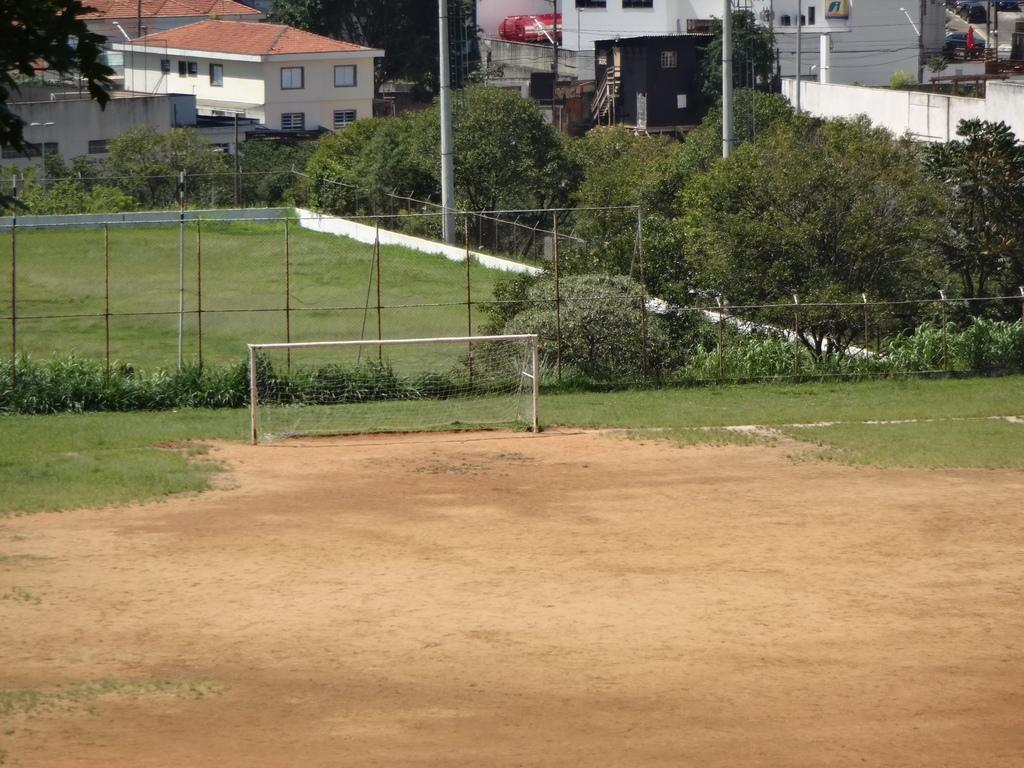What type of barrier can be seen in the image? There is a fence in the image. What type of vegetation is present in the image? There are plants, trees, and grass in the image. What type of structures can be seen in the image? There are buildings in the image. What type of pan is being used to cook the plants in the image? There is no pan or cooking activity present in the image. What type of pain is being experienced by the trees in the image? There is no indication of pain or any negative condition affecting the trees in the image. 